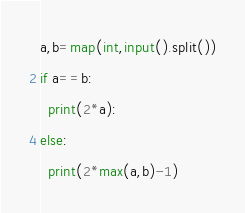<code> <loc_0><loc_0><loc_500><loc_500><_Python_>a,b=map(int,input().split())
if a==b:
  print(2*a):
else:
  print(2*max(a,b)-1)</code> 